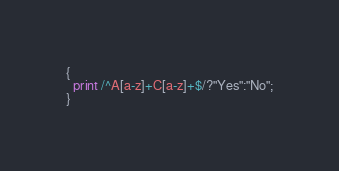Convert code to text. <code><loc_0><loc_0><loc_500><loc_500><_Awk_>{
  print /^A[a-z]+C[a-z]+$/?"Yes":"No";
}</code> 